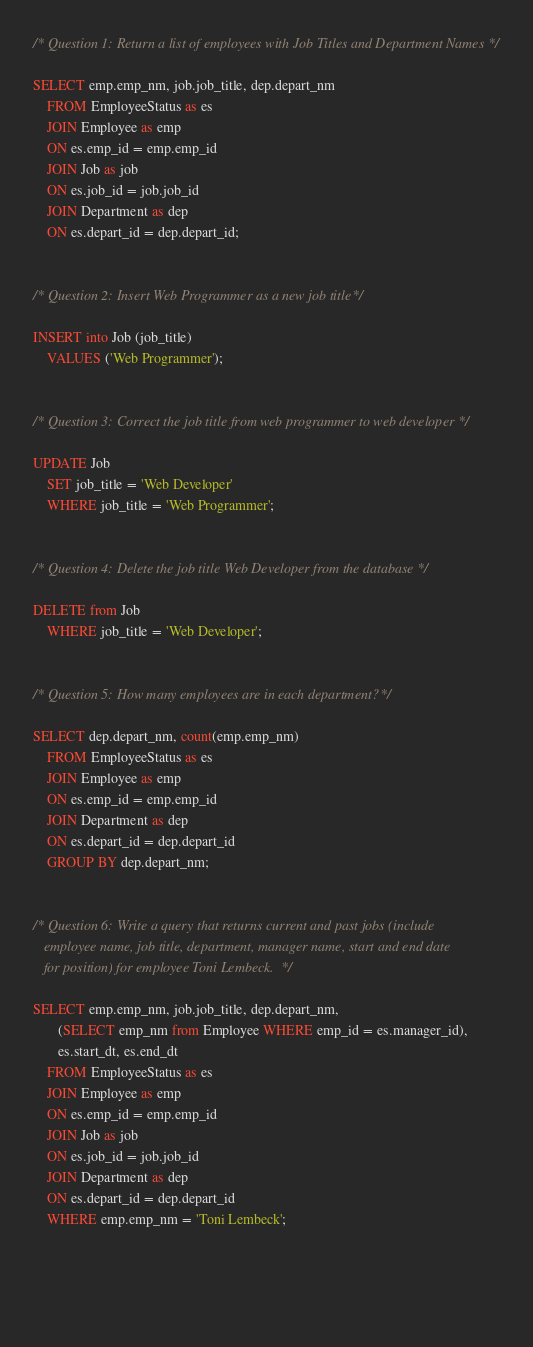Convert code to text. <code><loc_0><loc_0><loc_500><loc_500><_SQL_>/* Question 1: Return a list of employees with Job Titles and Department Names */

SELECT emp.emp_nm, job.job_title, dep.depart_nm
    FROM EmployeeStatus as es
    JOIN Employee as emp
    ON es.emp_id = emp.emp_id
    JOIN Job as job
    ON es.job_id = job.job_id
    JOIN Department as dep
    ON es.depart_id = dep.depart_id;
    
    
/* Question 2: Insert Web Programmer as a new job title */

INSERT into Job (job_title)
    VALUES ('Web Programmer');
    
    
/* Question 3: Correct the job title from web programmer to web developer */

UPDATE Job
    SET job_title = 'Web Developer'
    WHERE job_title = 'Web Programmer';
    
    
/* Question 4: Delete the job title Web Developer from the database */

DELETE from Job
    WHERE job_title = 'Web Developer';
    
    
/* Question 5: How many employees are in each department? */

SELECT dep.depart_nm, count(emp.emp_nm)
    FROM EmployeeStatus as es
    JOIN Employee as emp
    ON es.emp_id = emp.emp_id
    JOIN Department as dep
    ON es.depart_id = dep.depart_id
    GROUP BY dep.depart_nm;
    
    
/* Question 6: Write a query that returns current and past jobs (include 
   employee name, job title, department, manager name, start and end date 
   for position) for employee Toni Lembeck. */
   
SELECT emp.emp_nm, job.job_title, dep.depart_nm, 
       (SELECT emp_nm from Employee WHERE emp_id = es.manager_id),
       es.start_dt, es.end_dt
    FROM EmployeeStatus as es
    JOIN Employee as emp
    ON es.emp_id = emp.emp_id
    JOIN Job as job
    ON es.job_id = job.job_id
    JOIN Department as dep
    ON es.depart_id = dep.depart_id
    WHERE emp.emp_nm = 'Toni Lembeck';
    
    
    
    

</code> 